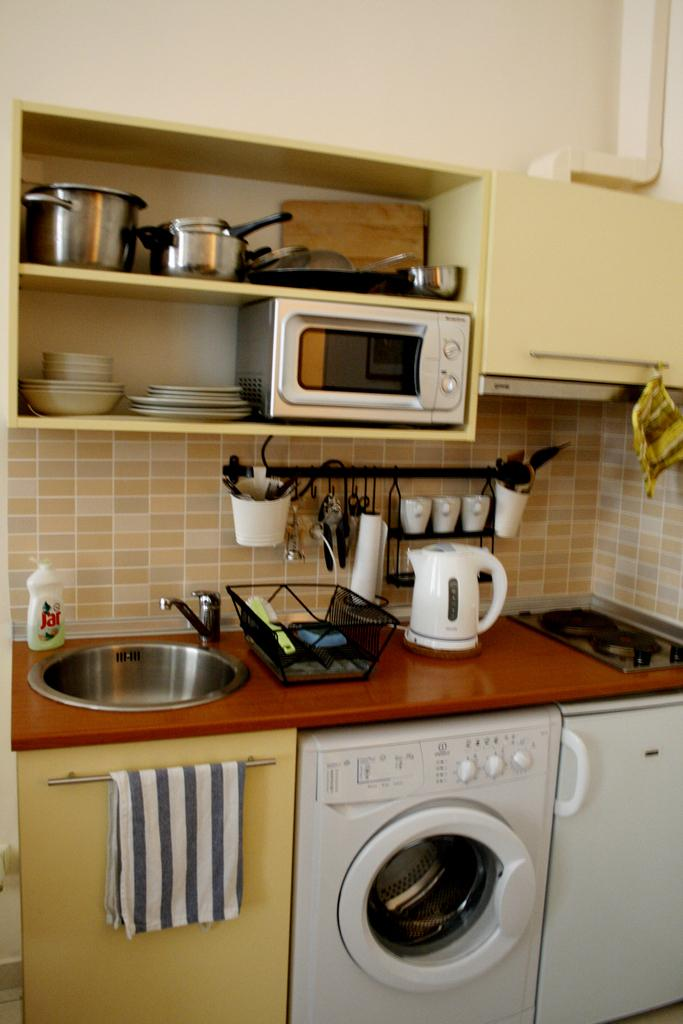What type of container is present in the image? There are containers in the image. What is used for washing hands in the image? There is a hand wash in the image. What is used for holding water in the image? There is a jug in the image. What is used for drying hands in the image? There is a napkin in the image. What is used for cooking in the image? There is a stove in the image. What is used for washing dishes in the image? There is a washbasin in the image. What is used for holding utensils in the image? There is a basket in the image. What is used for cutting in the image? There is a knife in the image. What is used for serving food in the image? There is a plate in the image. How does the image demonstrate respect for the environment? The image does not demonstrate respect for the environment, as it is a still image and does not show any actions or behaviors. What type of acoustics can be heard in the image? There are no sounds or acoustics present in the image, as it is a still image. 